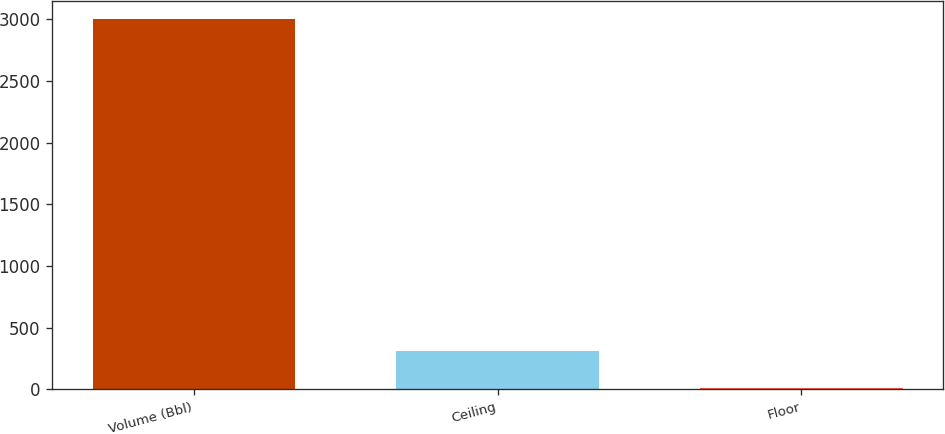Convert chart. <chart><loc_0><loc_0><loc_500><loc_500><bar_chart><fcel>Volume (Bbl)<fcel>Ceiling<fcel>Floor<nl><fcel>3000<fcel>307.81<fcel>8.68<nl></chart> 